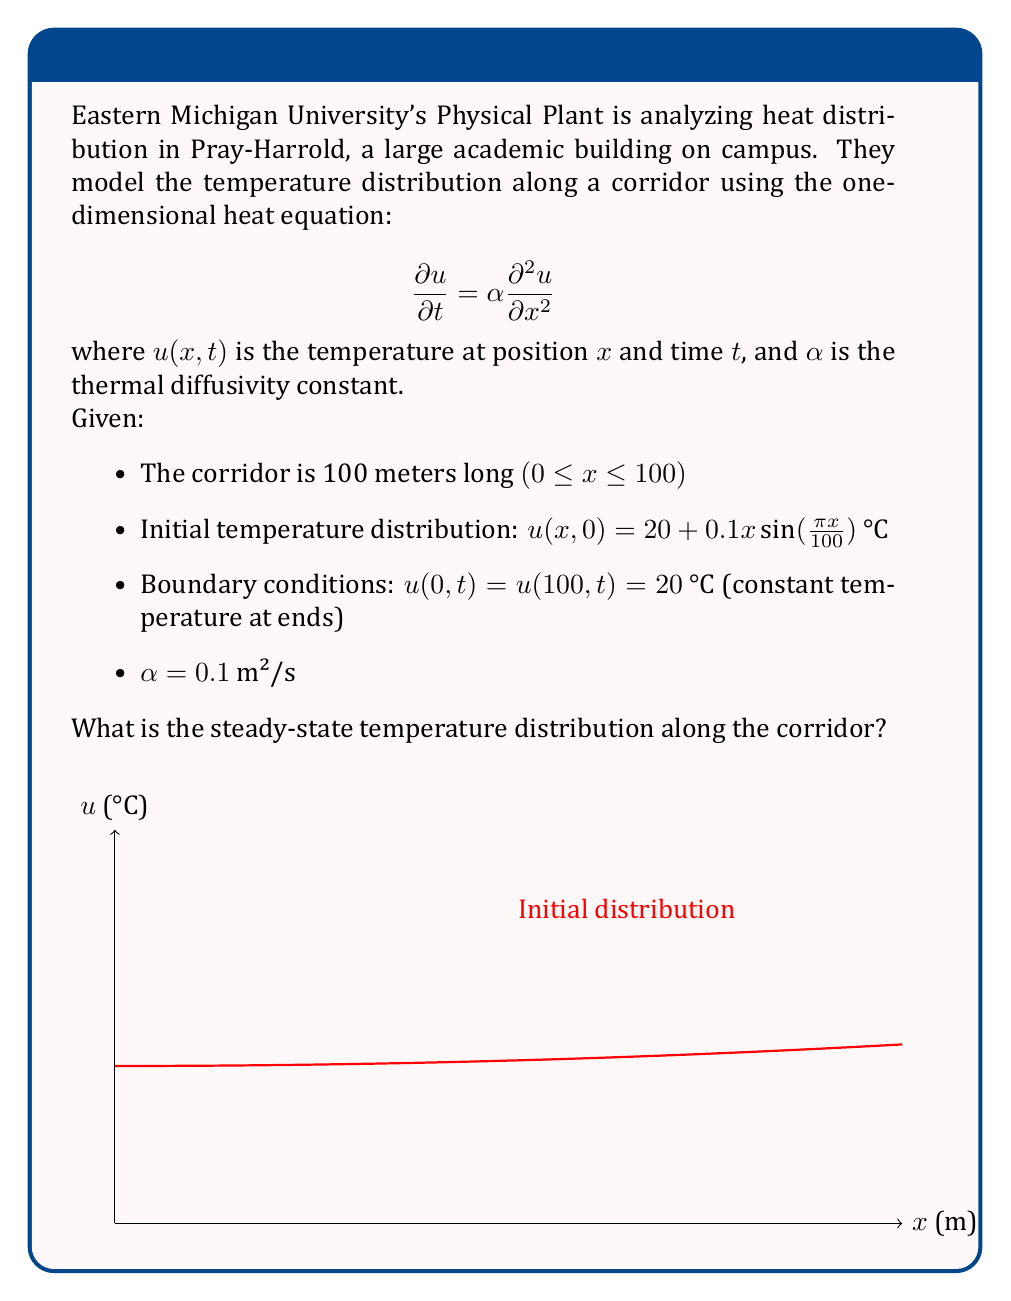Show me your answer to this math problem. To find the steady-state temperature distribution, we need to solve the heat equation when the temperature no longer changes with time. This means:

1) Set $\frac{\partial u}{\partial t} = 0$ in the heat equation:

   $$0 = \alpha \frac{\partial^2 u}{\partial x^2}$$

2) This simplifies to:

   $$\frac{\partial^2 u}{\partial x^2} = 0$$

3) Integrate twice with respect to x:

   $$\frac{\partial u}{\partial x} = C_1$$
   $$u(x) = C_1x + C_2$$

   where $C_1$ and $C_2$ are constants of integration.

4) Apply the boundary conditions:

   At x = 0: $u(0) = 20 = C_2$
   At x = 100: $u(100) = 20 = 100C_1 + C_2 = 100C_1 + 20$

5) Solve for $C_1$:

   $100C_1 = 0$
   $C_1 = 0$

6) Therefore, the steady-state solution is:

   $$u(x) = 20$$

This means that, at steady state, the temperature along the corridor will be uniformly 20°C, regardless of the initial distribution.
Answer: $u(x) = 20$ °C 